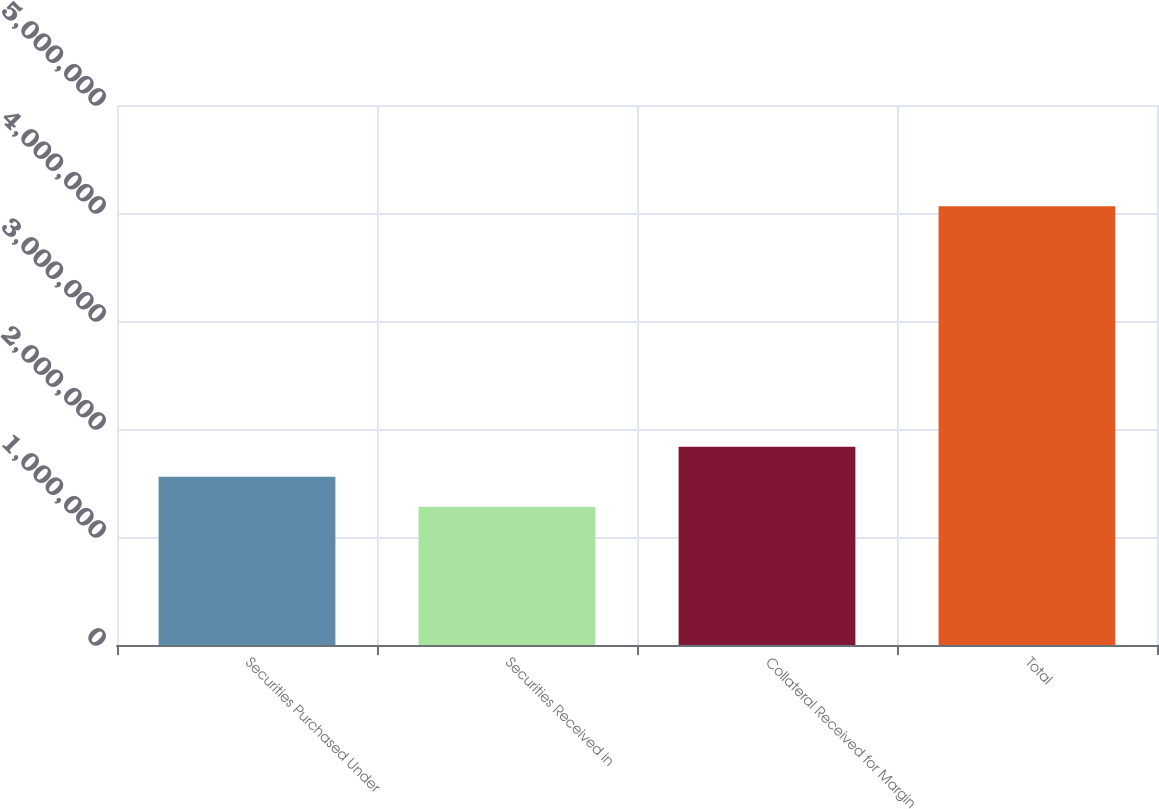Convert chart to OTSL. <chart><loc_0><loc_0><loc_500><loc_500><bar_chart><fcel>Securities Purchased Under<fcel>Securities Received in<fcel>Collateral Received for Margin<fcel>Total<nl><fcel>1.55745e+06<fcel>1.27913e+06<fcel>1.83577e+06<fcel>4.06236e+06<nl></chart> 